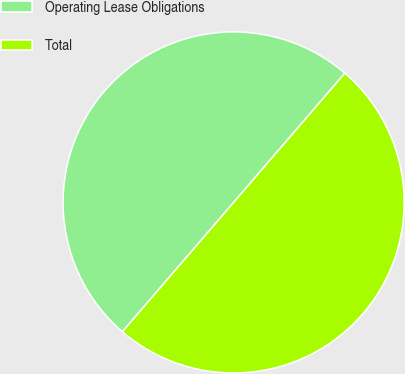Convert chart to OTSL. <chart><loc_0><loc_0><loc_500><loc_500><pie_chart><fcel>Operating Lease Obligations<fcel>Total<nl><fcel>50.0%<fcel>50.0%<nl></chart> 